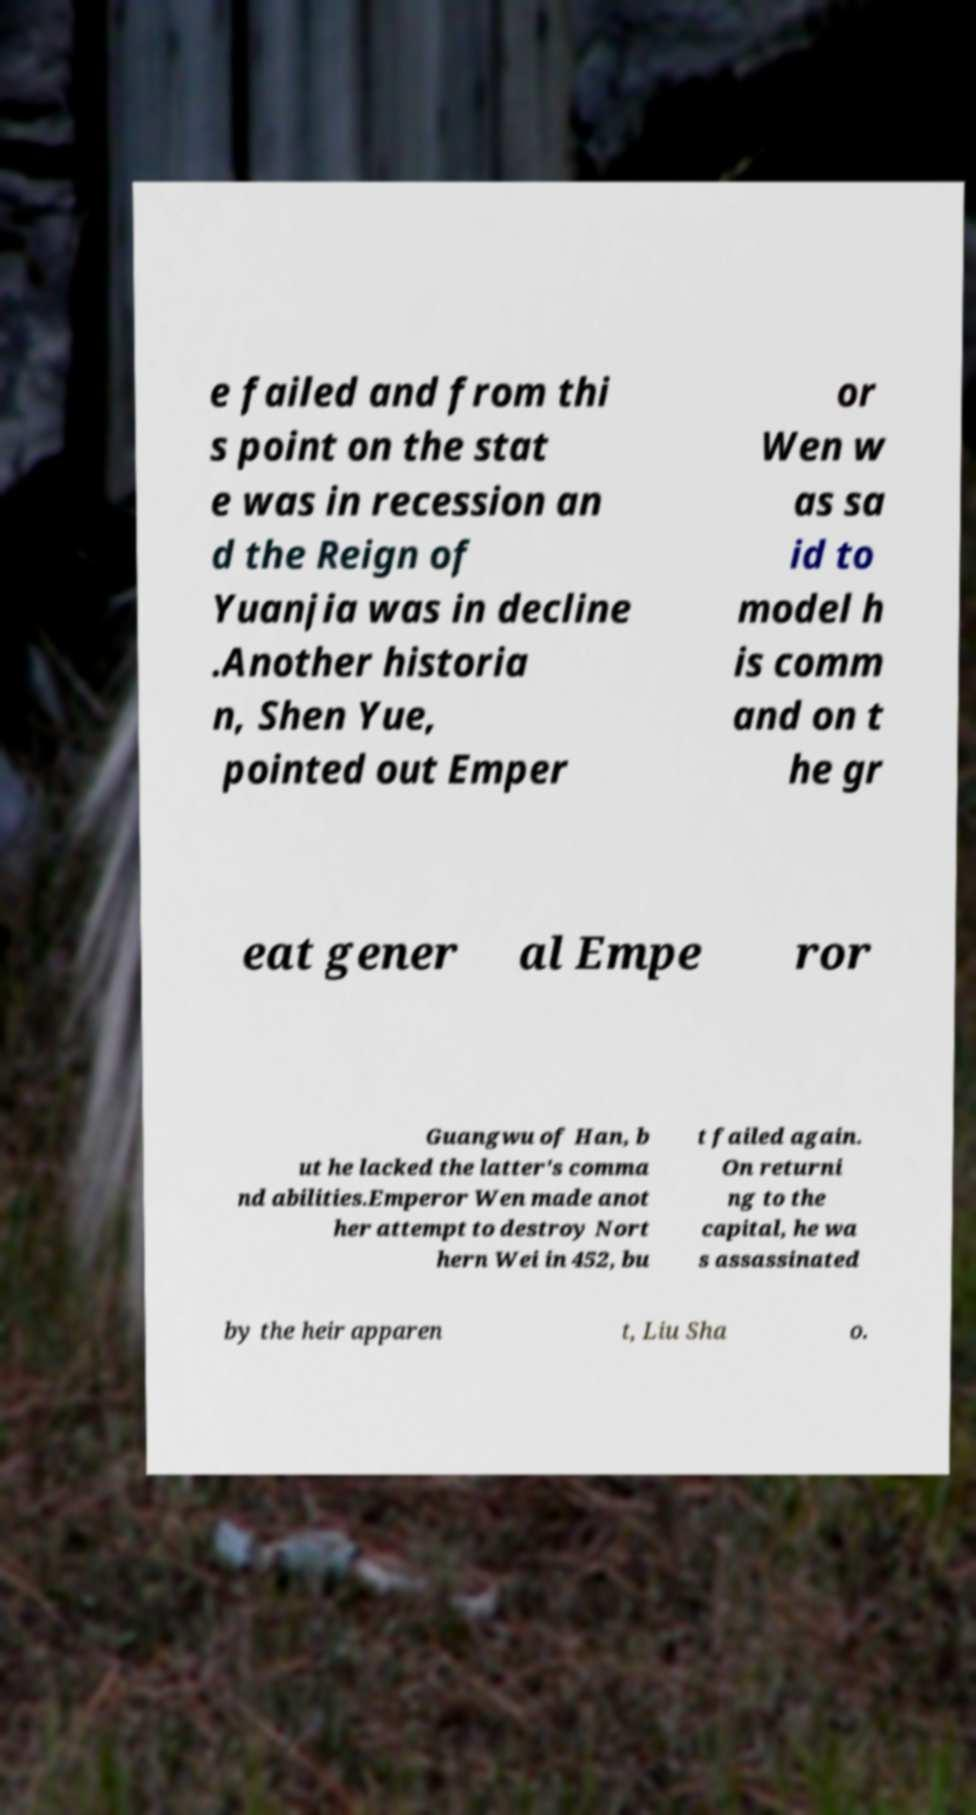Please read and relay the text visible in this image. What does it say? e failed and from thi s point on the stat e was in recession an d the Reign of Yuanjia was in decline .Another historia n, Shen Yue, pointed out Emper or Wen w as sa id to model h is comm and on t he gr eat gener al Empe ror Guangwu of Han, b ut he lacked the latter's comma nd abilities.Emperor Wen made anot her attempt to destroy Nort hern Wei in 452, bu t failed again. On returni ng to the capital, he wa s assassinated by the heir apparen t, Liu Sha o. 